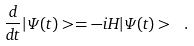<formula> <loc_0><loc_0><loc_500><loc_500>\frac { d } { d t } | \Psi ( t ) > = - i H | \Psi ( t ) > \ .</formula> 